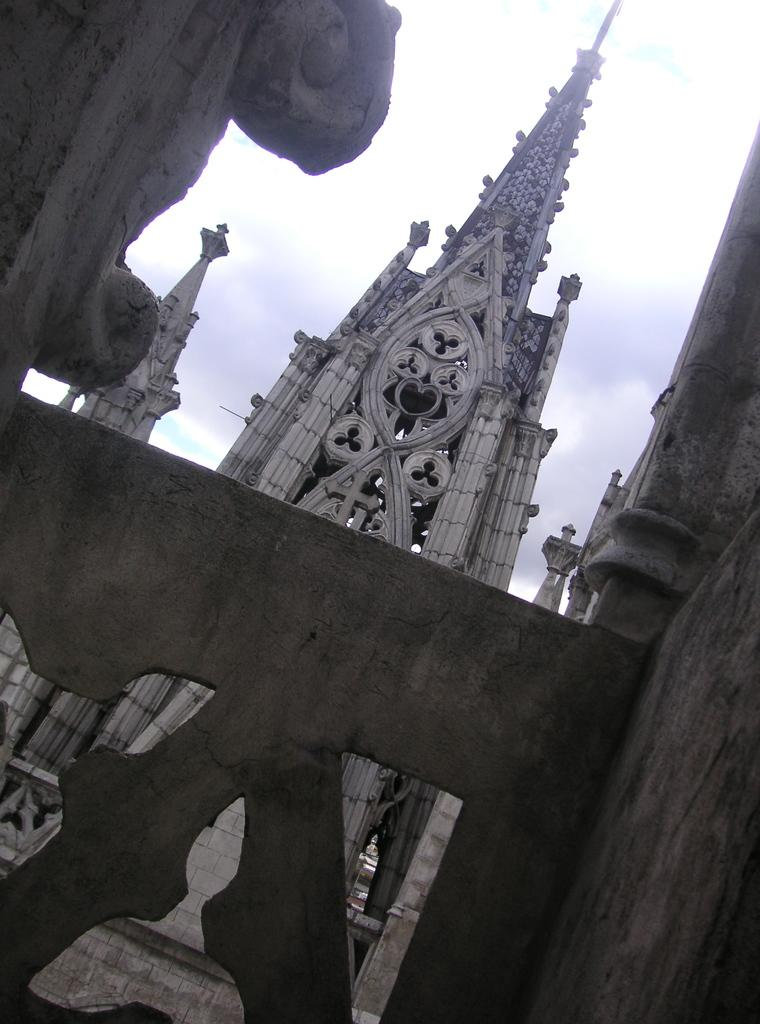What type of structure is present in the image? There is a building in the picture. What can be seen in the background of the image? The sky is visible in the background of the picture. What is the price of the show that is taking place in the building? There is no show taking place in the building, and therefore no price can be determined. 